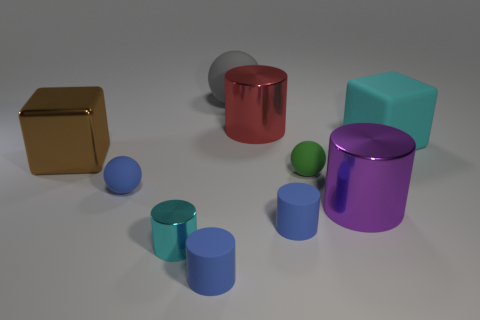There is a tiny metal cylinder; are there any matte objects in front of it?
Offer a terse response. Yes. What number of objects are either cubes to the left of the gray object or big brown metallic blocks?
Provide a succinct answer. 1. How many green objects are large rubber objects or big matte spheres?
Your response must be concise. 0. How many other things are the same color as the big rubber ball?
Your response must be concise. 0. Is the number of tiny green rubber balls left of the tiny green ball less than the number of cyan things?
Ensure brevity in your answer.  Yes. The big cylinder that is in front of the brown block that is behind the big cylinder that is in front of the large red metallic object is what color?
Your response must be concise. Purple. Is there any other thing that has the same material as the large cyan object?
Give a very brief answer. Yes. There is a red metal thing that is the same shape as the big purple metallic object; what size is it?
Your answer should be very brief. Large. Are there fewer cyan cylinders that are behind the green matte ball than big gray matte balls that are on the left side of the tiny blue ball?
Offer a very short reply. No. What shape is the thing that is in front of the large shiny block and to the left of the small cyan object?
Give a very brief answer. Sphere. 